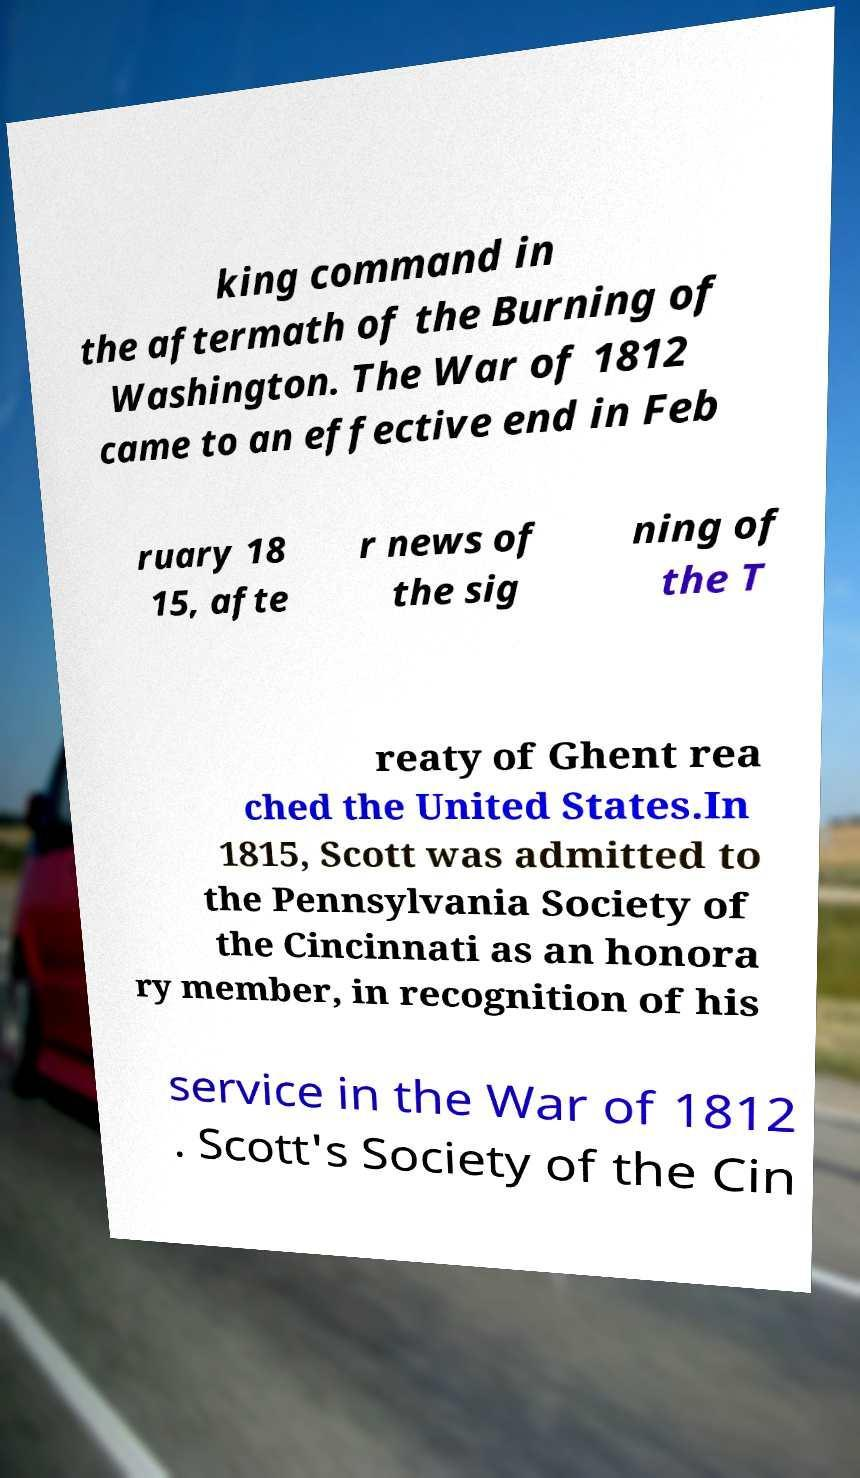Please read and relay the text visible in this image. What does it say? king command in the aftermath of the Burning of Washington. The War of 1812 came to an effective end in Feb ruary 18 15, afte r news of the sig ning of the T reaty of Ghent rea ched the United States.In 1815, Scott was admitted to the Pennsylvania Society of the Cincinnati as an honora ry member, in recognition of his service in the War of 1812 . Scott's Society of the Cin 